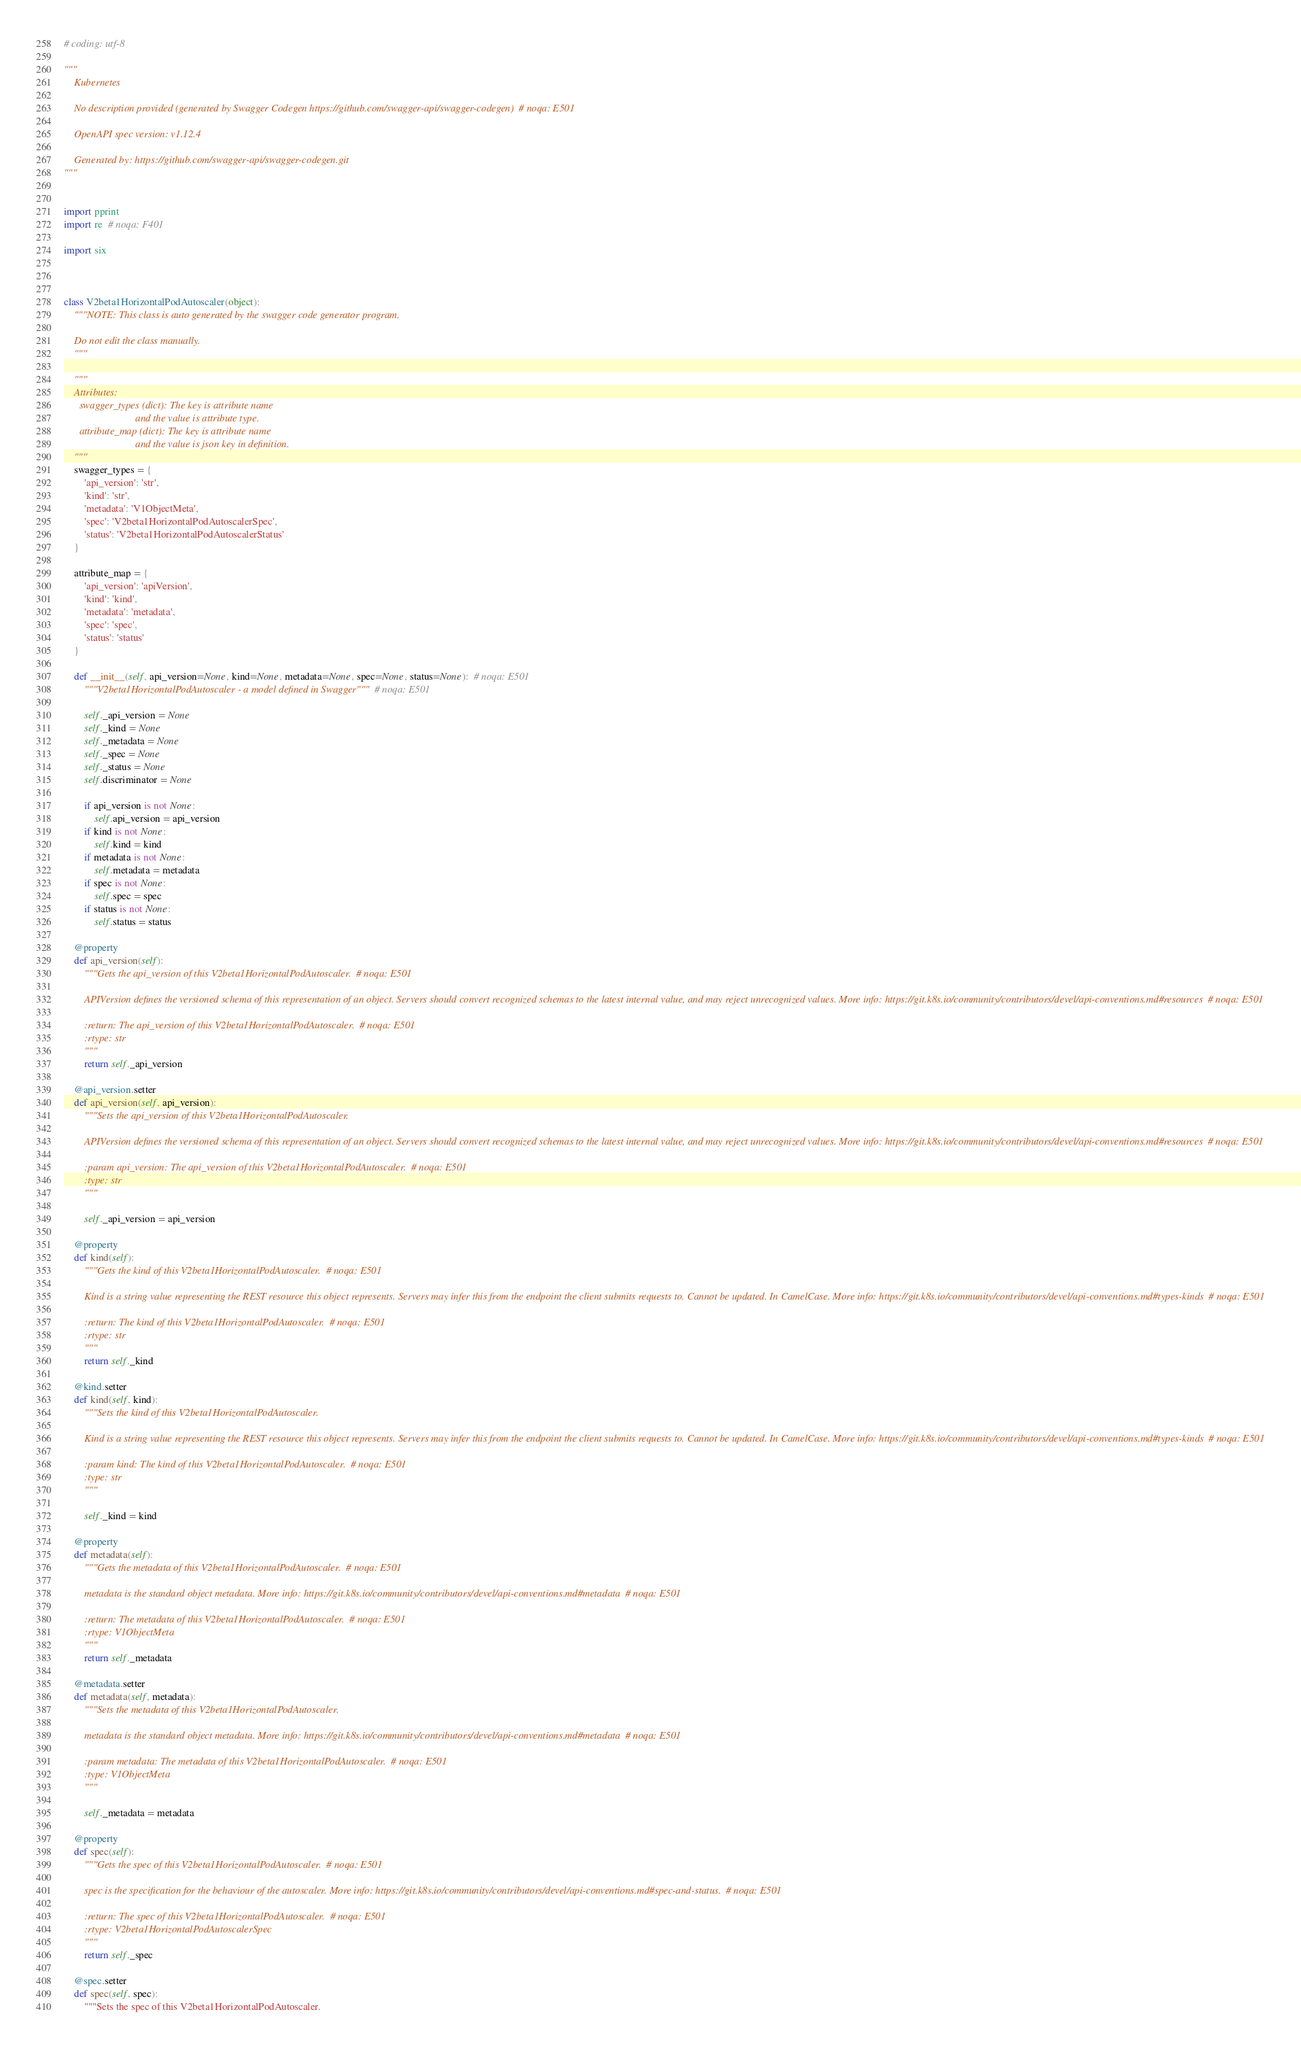Convert code to text. <code><loc_0><loc_0><loc_500><loc_500><_Python_># coding: utf-8

"""
    Kubernetes

    No description provided (generated by Swagger Codegen https://github.com/swagger-api/swagger-codegen)  # noqa: E501

    OpenAPI spec version: v1.12.4
    
    Generated by: https://github.com/swagger-api/swagger-codegen.git
"""


import pprint
import re  # noqa: F401

import six



class V2beta1HorizontalPodAutoscaler(object):
    """NOTE: This class is auto generated by the swagger code generator program.

    Do not edit the class manually.
    """

    """
    Attributes:
      swagger_types (dict): The key is attribute name
                            and the value is attribute type.
      attribute_map (dict): The key is attribute name
                            and the value is json key in definition.
    """
    swagger_types = {
        'api_version': 'str',
        'kind': 'str',
        'metadata': 'V1ObjectMeta',
        'spec': 'V2beta1HorizontalPodAutoscalerSpec',
        'status': 'V2beta1HorizontalPodAutoscalerStatus'
    }

    attribute_map = {
        'api_version': 'apiVersion',
        'kind': 'kind',
        'metadata': 'metadata',
        'spec': 'spec',
        'status': 'status'
    }

    def __init__(self, api_version=None, kind=None, metadata=None, spec=None, status=None):  # noqa: E501
        """V2beta1HorizontalPodAutoscaler - a model defined in Swagger"""  # noqa: E501

        self._api_version = None
        self._kind = None
        self._metadata = None
        self._spec = None
        self._status = None
        self.discriminator = None

        if api_version is not None:
            self.api_version = api_version
        if kind is not None:
            self.kind = kind
        if metadata is not None:
            self.metadata = metadata
        if spec is not None:
            self.spec = spec
        if status is not None:
            self.status = status

    @property
    def api_version(self):
        """Gets the api_version of this V2beta1HorizontalPodAutoscaler.  # noqa: E501

        APIVersion defines the versioned schema of this representation of an object. Servers should convert recognized schemas to the latest internal value, and may reject unrecognized values. More info: https://git.k8s.io/community/contributors/devel/api-conventions.md#resources  # noqa: E501

        :return: The api_version of this V2beta1HorizontalPodAutoscaler.  # noqa: E501
        :rtype: str
        """
        return self._api_version

    @api_version.setter
    def api_version(self, api_version):
        """Sets the api_version of this V2beta1HorizontalPodAutoscaler.

        APIVersion defines the versioned schema of this representation of an object. Servers should convert recognized schemas to the latest internal value, and may reject unrecognized values. More info: https://git.k8s.io/community/contributors/devel/api-conventions.md#resources  # noqa: E501

        :param api_version: The api_version of this V2beta1HorizontalPodAutoscaler.  # noqa: E501
        :type: str
        """

        self._api_version = api_version

    @property
    def kind(self):
        """Gets the kind of this V2beta1HorizontalPodAutoscaler.  # noqa: E501

        Kind is a string value representing the REST resource this object represents. Servers may infer this from the endpoint the client submits requests to. Cannot be updated. In CamelCase. More info: https://git.k8s.io/community/contributors/devel/api-conventions.md#types-kinds  # noqa: E501

        :return: The kind of this V2beta1HorizontalPodAutoscaler.  # noqa: E501
        :rtype: str
        """
        return self._kind

    @kind.setter
    def kind(self, kind):
        """Sets the kind of this V2beta1HorizontalPodAutoscaler.

        Kind is a string value representing the REST resource this object represents. Servers may infer this from the endpoint the client submits requests to. Cannot be updated. In CamelCase. More info: https://git.k8s.io/community/contributors/devel/api-conventions.md#types-kinds  # noqa: E501

        :param kind: The kind of this V2beta1HorizontalPodAutoscaler.  # noqa: E501
        :type: str
        """

        self._kind = kind

    @property
    def metadata(self):
        """Gets the metadata of this V2beta1HorizontalPodAutoscaler.  # noqa: E501

        metadata is the standard object metadata. More info: https://git.k8s.io/community/contributors/devel/api-conventions.md#metadata  # noqa: E501

        :return: The metadata of this V2beta1HorizontalPodAutoscaler.  # noqa: E501
        :rtype: V1ObjectMeta
        """
        return self._metadata

    @metadata.setter
    def metadata(self, metadata):
        """Sets the metadata of this V2beta1HorizontalPodAutoscaler.

        metadata is the standard object metadata. More info: https://git.k8s.io/community/contributors/devel/api-conventions.md#metadata  # noqa: E501

        :param metadata: The metadata of this V2beta1HorizontalPodAutoscaler.  # noqa: E501
        :type: V1ObjectMeta
        """

        self._metadata = metadata

    @property
    def spec(self):
        """Gets the spec of this V2beta1HorizontalPodAutoscaler.  # noqa: E501

        spec is the specification for the behaviour of the autoscaler. More info: https://git.k8s.io/community/contributors/devel/api-conventions.md#spec-and-status.  # noqa: E501

        :return: The spec of this V2beta1HorizontalPodAutoscaler.  # noqa: E501
        :rtype: V2beta1HorizontalPodAutoscalerSpec
        """
        return self._spec

    @spec.setter
    def spec(self, spec):
        """Sets the spec of this V2beta1HorizontalPodAutoscaler.
</code> 